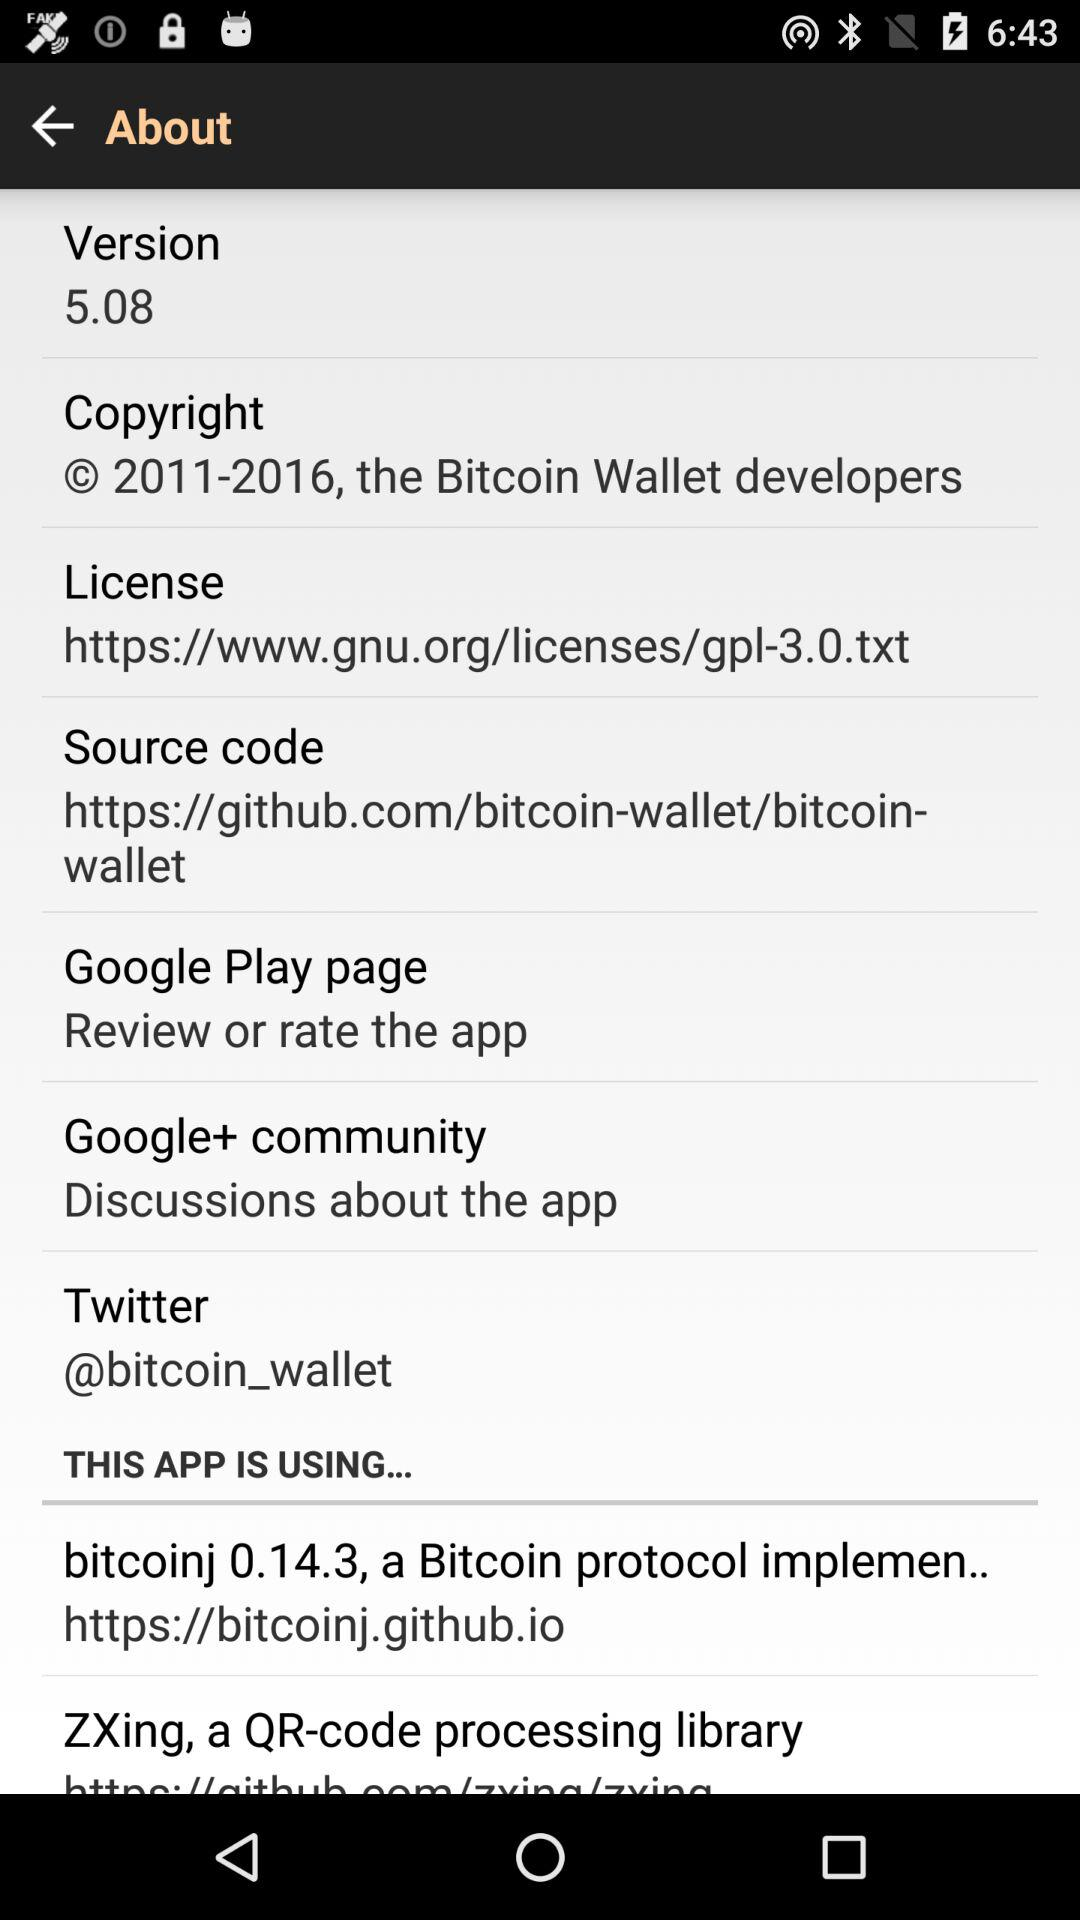How much data does this application take?
When the provided information is insufficient, respond with <no answer>. <no answer> 